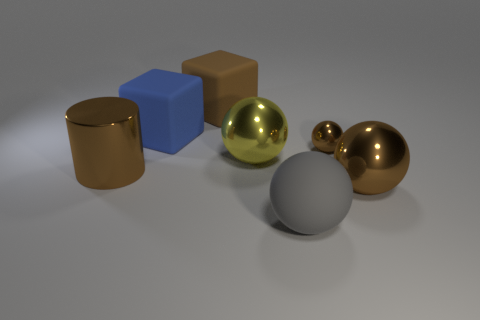What number of things are either brown objects that are to the right of the large matte ball or yellow objects?
Keep it short and to the point. 3. How many objects are either blocks or metal objects on the right side of the gray rubber sphere?
Keep it short and to the point. 4. What number of blue blocks have the same size as the brown matte cube?
Provide a short and direct response. 1. Are there fewer big spheres that are behind the tiny brown metallic object than things to the left of the yellow metallic thing?
Make the answer very short. Yes. How many shiny things are big yellow spheres or big purple cubes?
Provide a succinct answer. 1. The small brown shiny object is what shape?
Provide a succinct answer. Sphere. There is a cylinder that is the same size as the blue matte block; what is its material?
Your response must be concise. Metal. How many large objects are matte spheres or yellow metallic objects?
Make the answer very short. 2. Are there any big blue things?
Your response must be concise. Yes. There is another brown ball that is the same material as the big brown sphere; what size is it?
Keep it short and to the point. Small. 